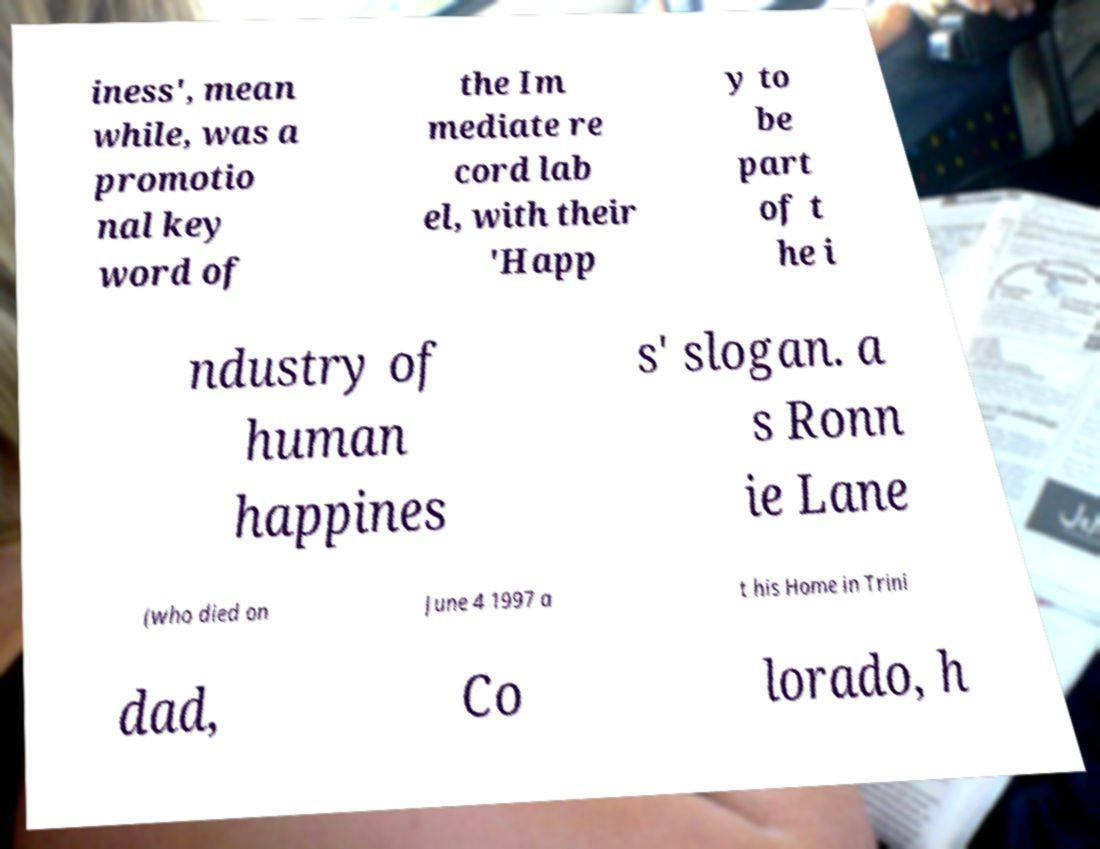Could you extract and type out the text from this image? iness', mean while, was a promotio nal key word of the Im mediate re cord lab el, with their 'Happ y to be part of t he i ndustry of human happines s' slogan. a s Ronn ie Lane (who died on June 4 1997 a t his Home in Trini dad, Co lorado, h 